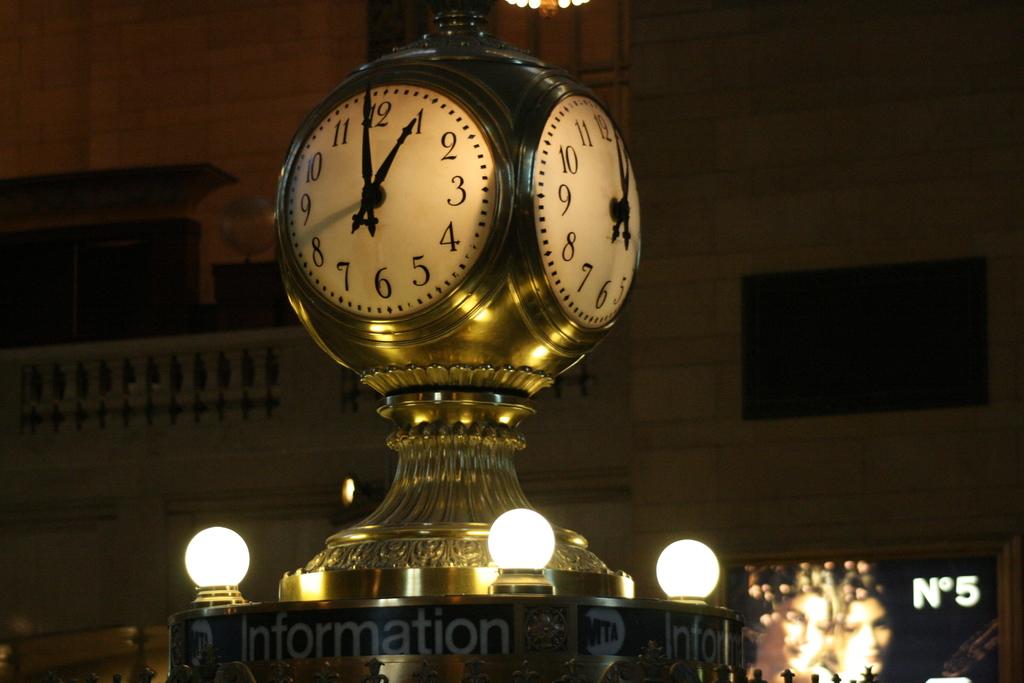What time is it in london at the moment?
Your response must be concise. 1:00. What is that place used for?
Your response must be concise. Information. 